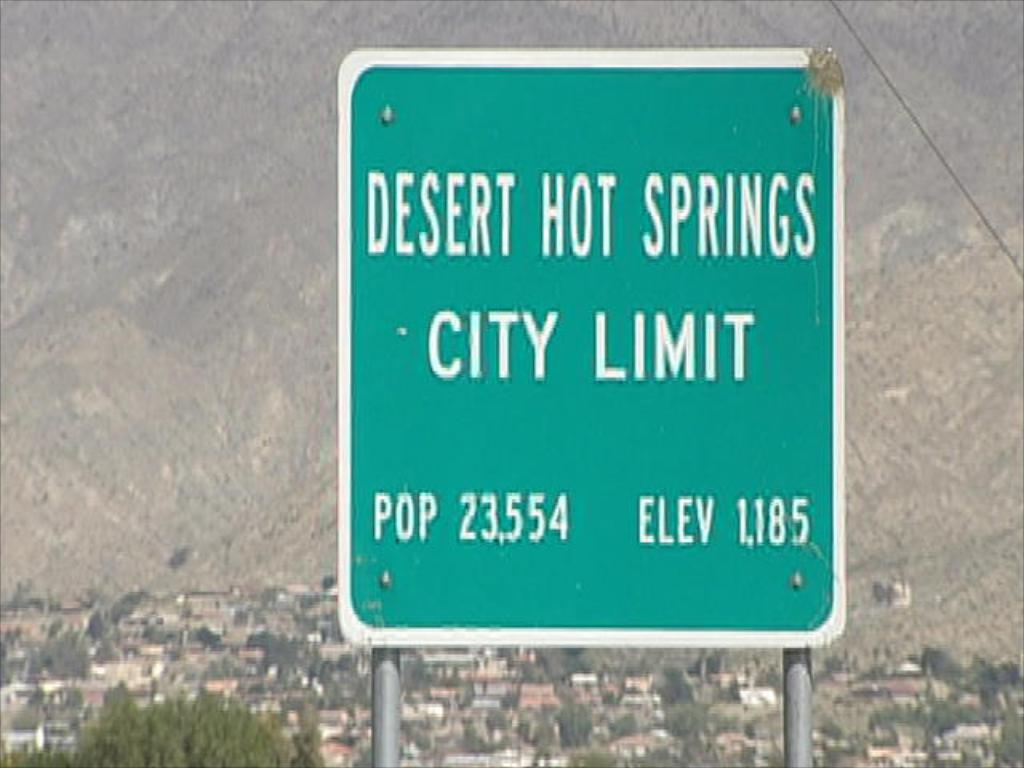Provide a one-sentence caption for the provided image. A population and elevation sign for Desert Hot Springs in front of the city. 